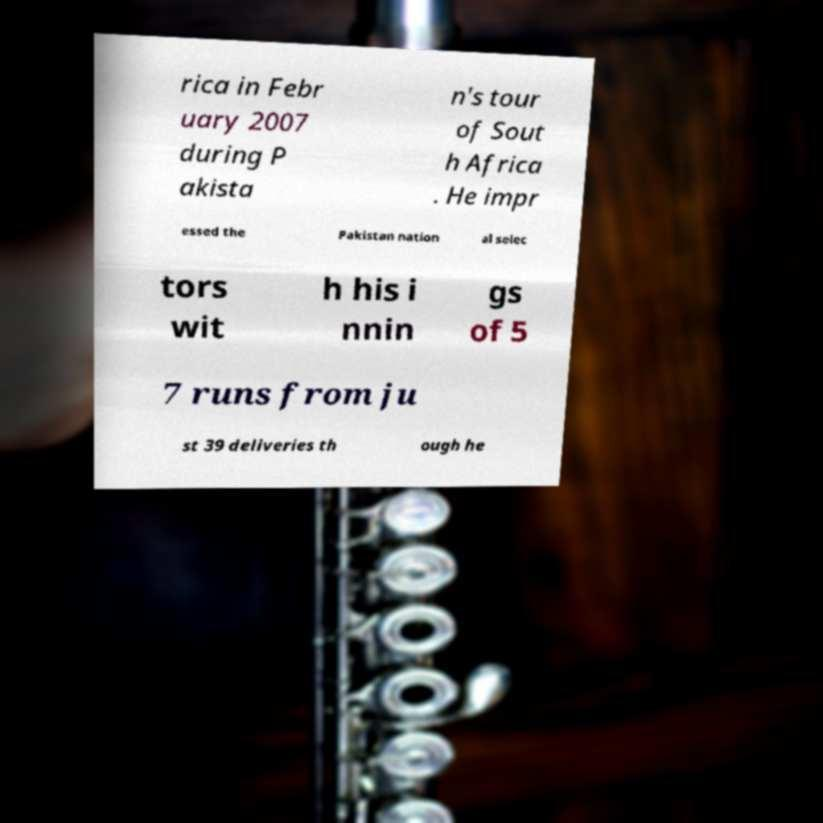What messages or text are displayed in this image? I need them in a readable, typed format. rica in Febr uary 2007 during P akista n's tour of Sout h Africa . He impr essed the Pakistan nation al selec tors wit h his i nnin gs of 5 7 runs from ju st 39 deliveries th ough he 